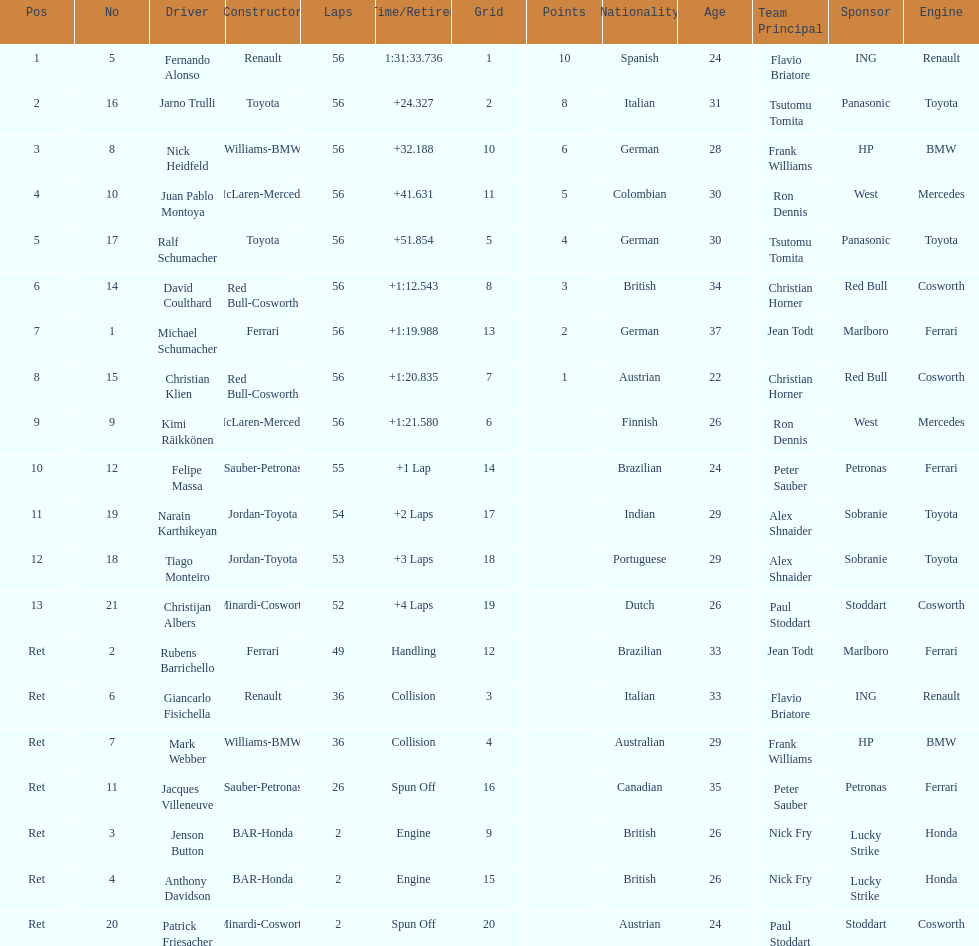How long did it take for heidfeld to finish? 1:31:65.924. 